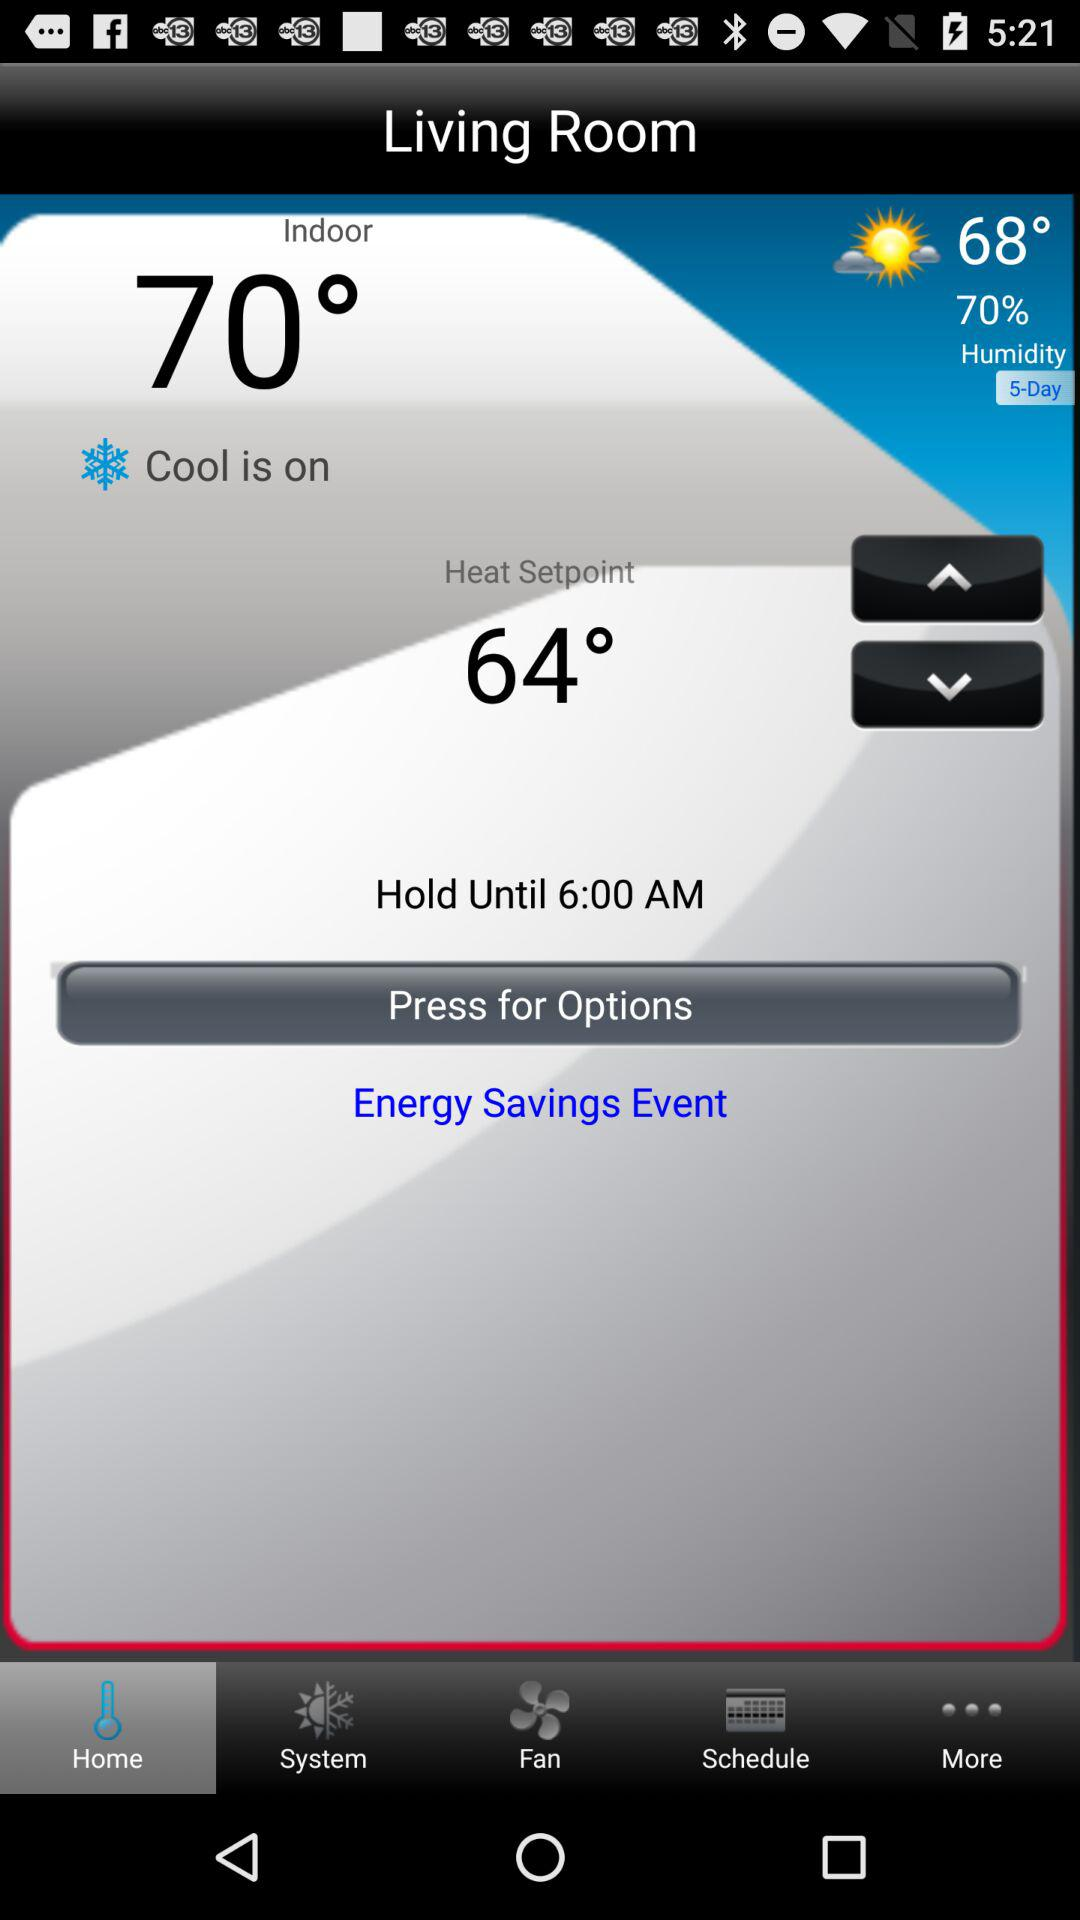What is the humidity percentage? The humidity percentage is 70. 